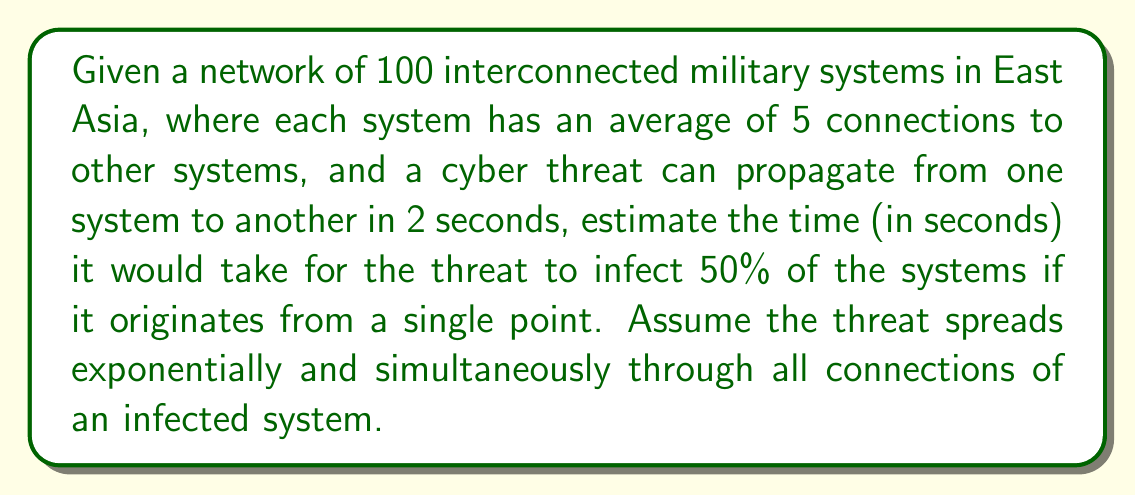Could you help me with this problem? To solve this problem, we'll use concepts from network theory and exponential growth:

1) First, let's define our variables:
   $n$ = total number of systems = 100
   $c$ = average connections per system = 5
   $t$ = time for threat to propagate between two systems = 2 seconds
   $x$ = number of infected systems after $i$ iterations

2) In each iteration, the number of newly infected systems is:
   $x_{new} = x_{current} \cdot c$

3) The number of infected systems after $i$ iterations is:
   $x_i = 1 + 5 + 5^2 + ... + 5^{i-1} = \frac{5^i - 1}{4}$

4) We want to find $i$ when $x_i \geq 50$ (50% of 100 systems):
   $$\frac{5^i - 1}{4} \geq 50$$
   $$5^i - 1 \geq 200$$
   $$5^i \geq 201$$
   $$i \geq \log_5(201) \approx 3.82$$

5) Since $i$ must be an integer, we round up to 4 iterations.

6) The total time is:
   $T = 4 \cdot 2 = 8$ seconds

Therefore, it would take approximately 8 seconds for the cyber threat to infect 50% of the systems.
Answer: 8 seconds 